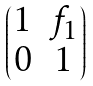<formula> <loc_0><loc_0><loc_500><loc_500>\begin{pmatrix} 1 & f _ { 1 } \\ 0 & 1 \end{pmatrix}</formula> 